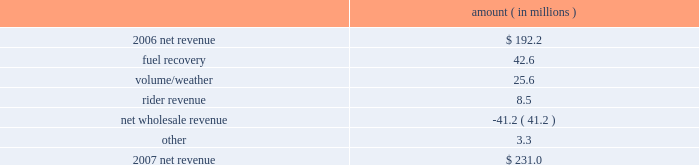Entergy new orleans , inc .
Management's financial discussion and analysis 2007 compared to 2006 net revenue consists of operating revenues net of : 1 ) fuel , fuel-related expenses , and gas purchased for resale , 2 ) purchased power expenses , and 3 ) other regulatory charges .
Following is an analysis of the change in net revenue comparing 2007 to 2006 .
Amount ( in millions ) .
The fuel recovery variance is due to the inclusion of grand gulf costs in fuel recoveries effective july 1 , 2006 .
In june 2006 , the city council approved the recovery of grand gulf costs through the fuel adjustment clause , without a corresponding change in base rates ( a significant portion of grand gulf costs was previously recovered through base rates ) .
The volume/weather variance is due to an increase in electricity usage in the service territory in 2007 compared to the same period in 2006 .
The first quarter 2006 was affected by customer losses following hurricane katrina .
Entergy new orleans estimates that approximately 132000 electric customers and 86000 gas customers have returned and are taking service as of december 31 , 2007 , compared to approximately 95000 electric customers and 65000 gas customers as of december 31 , 2006 .
Billed retail electricity usage increased a total of 540 gwh compared to the same period in 2006 , an increase of 14% ( 14 % ) .
The rider revenue variance is due primarily to a storm reserve rider effective march 2007 as a result of the city council's approval of a settlement agreement in october 2006 .
The approved storm reserve has been set to collect $ 75 million over a ten-year period through the rider and the funds will be held in a restricted escrow account .
The settlement agreement is discussed in note 2 to the financial statements .
The net wholesale revenue variance is due to more energy available for resale in 2006 due to the decrease in retail usage caused by customer losses following hurricane katrina .
In addition , 2006 revenue includes the sales into the wholesale market of entergy new orleans' share of the output of grand gulf , pursuant to city council approval of measures proposed by entergy new orleans to address the reduction in entergy new orleans' retail customer usage caused by hurricane katrina and to provide revenue support for the costs of entergy new orleans' share of grand other income statement variances 2008 compared to 2007 other operation and maintenance expenses decreased primarily due to : a provision for storm-related bad debts of $ 11 million recorded in 2007 ; a decrease of $ 6.2 million in legal and professional fees ; a decrease of $ 3.4 million in employee benefit expenses ; and a decrease of $ 1.9 million in gas operations spending due to higher labor and material costs for reliability work in 2007. .
What is the percent change in electric customers between 2006 and 2007? 
Computations: ((132000 - 95000) / 95000)
Answer: 0.38947. 